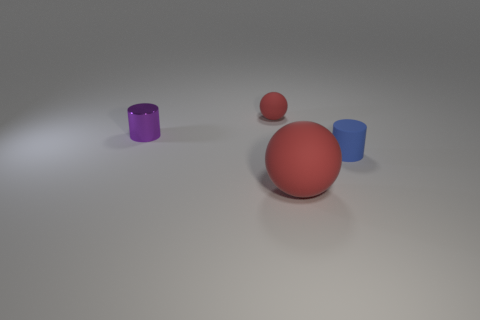Add 1 small blue rubber objects. How many objects exist? 5 Add 2 large brown blocks. How many large brown blocks exist? 2 Subtract 0 brown cylinders. How many objects are left? 4 Subtract all large rubber spheres. Subtract all tiny blue matte objects. How many objects are left? 2 Add 4 small red objects. How many small red objects are left? 5 